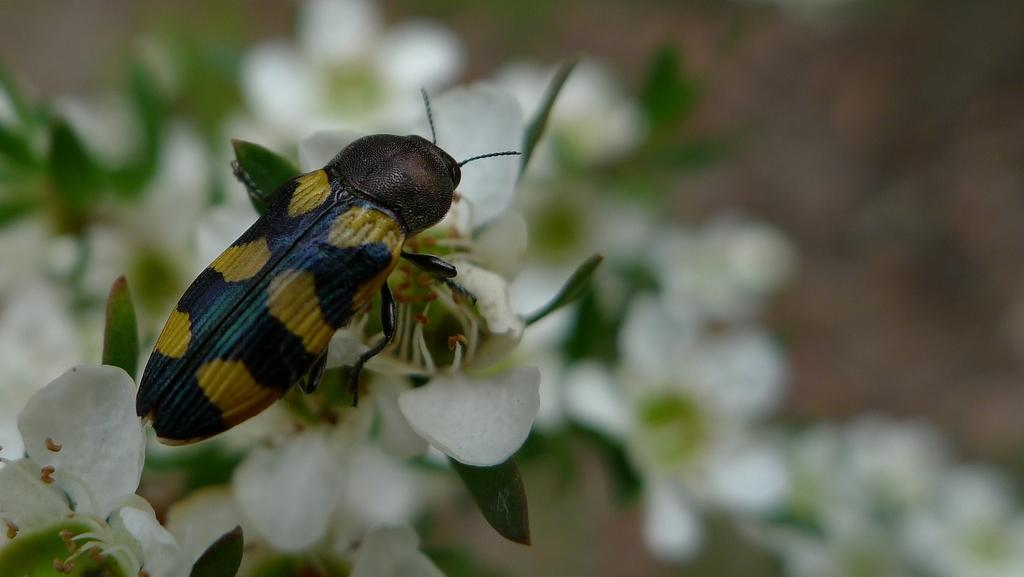What type of creature is present in the image? There is an insect in the image. What colors can be seen on the insect? The insect has black and yellow colors. What is the insect doing in the image? The insect is on white flowers. What type of lead is the minister using to touch the insect in the image? There is no minister or lead present in the image; it only features an insect on white flowers. 